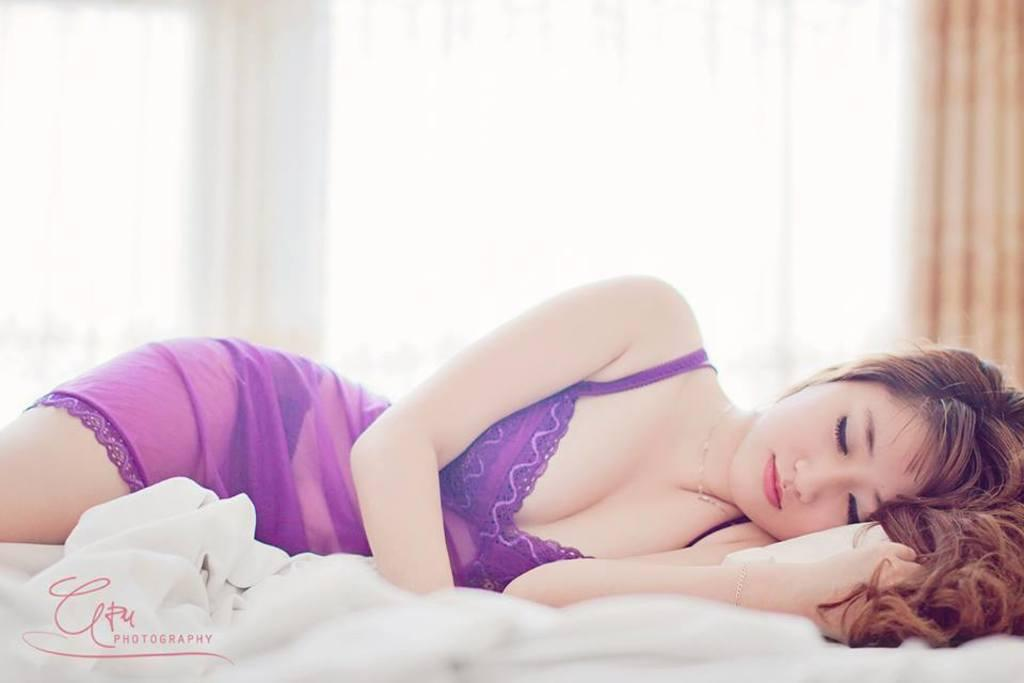Who is the main subject in the image? There is a lady in the image. What is the lady wearing? The lady is wearing a purple dress. What is the lady doing in the image? The lady is sleeping on the bed. What can be seen in the background of the image? There are curtains in the background of the image. Can you see any oil leaking from the lady's tooth in the image? There is no tooth or oil present in the image, and therefore no such leak can be observed. 